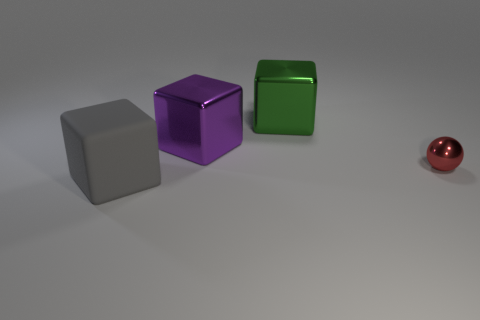Subtract all gray matte blocks. How many blocks are left? 2 Add 2 metal objects. How many objects exist? 6 Subtract all purple blocks. How many blocks are left? 2 Subtract all balls. How many objects are left? 3 Subtract 1 spheres. How many spheres are left? 0 Subtract all blue spheres. Subtract all purple cubes. How many spheres are left? 1 Subtract all yellow cubes. How many gray balls are left? 0 Subtract all red metal objects. Subtract all gray cubes. How many objects are left? 2 Add 3 red things. How many red things are left? 4 Add 3 tiny red matte cylinders. How many tiny red matte cylinders exist? 3 